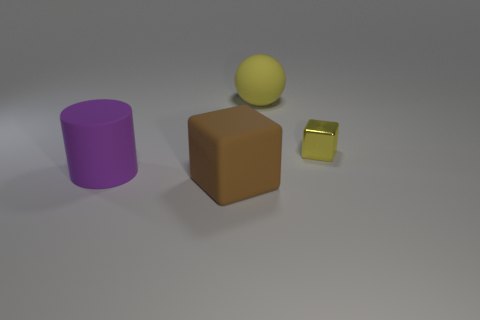What color is the matte cube?
Make the answer very short. Brown. How many other things are the same shape as the metallic object?
Provide a succinct answer. 1. Are there an equal number of yellow balls in front of the matte cube and shiny objects that are left of the yellow metal cube?
Your answer should be very brief. Yes. What is the tiny yellow object made of?
Your answer should be compact. Metal. There is a cube to the left of the yellow rubber object; what is its material?
Your answer should be very brief. Rubber. Is there any other thing that has the same material as the small thing?
Provide a succinct answer. No. Is the number of yellow cubes to the right of the yellow block greater than the number of small brown metal spheres?
Provide a succinct answer. No. Is there a tiny yellow shiny thing that is behind the yellow metallic cube that is in front of the big matte thing that is on the right side of the big cube?
Keep it short and to the point. No. Are there any large yellow rubber objects in front of the big yellow sphere?
Your answer should be compact. No. What number of tiny metal things are the same color as the tiny block?
Give a very brief answer. 0. 